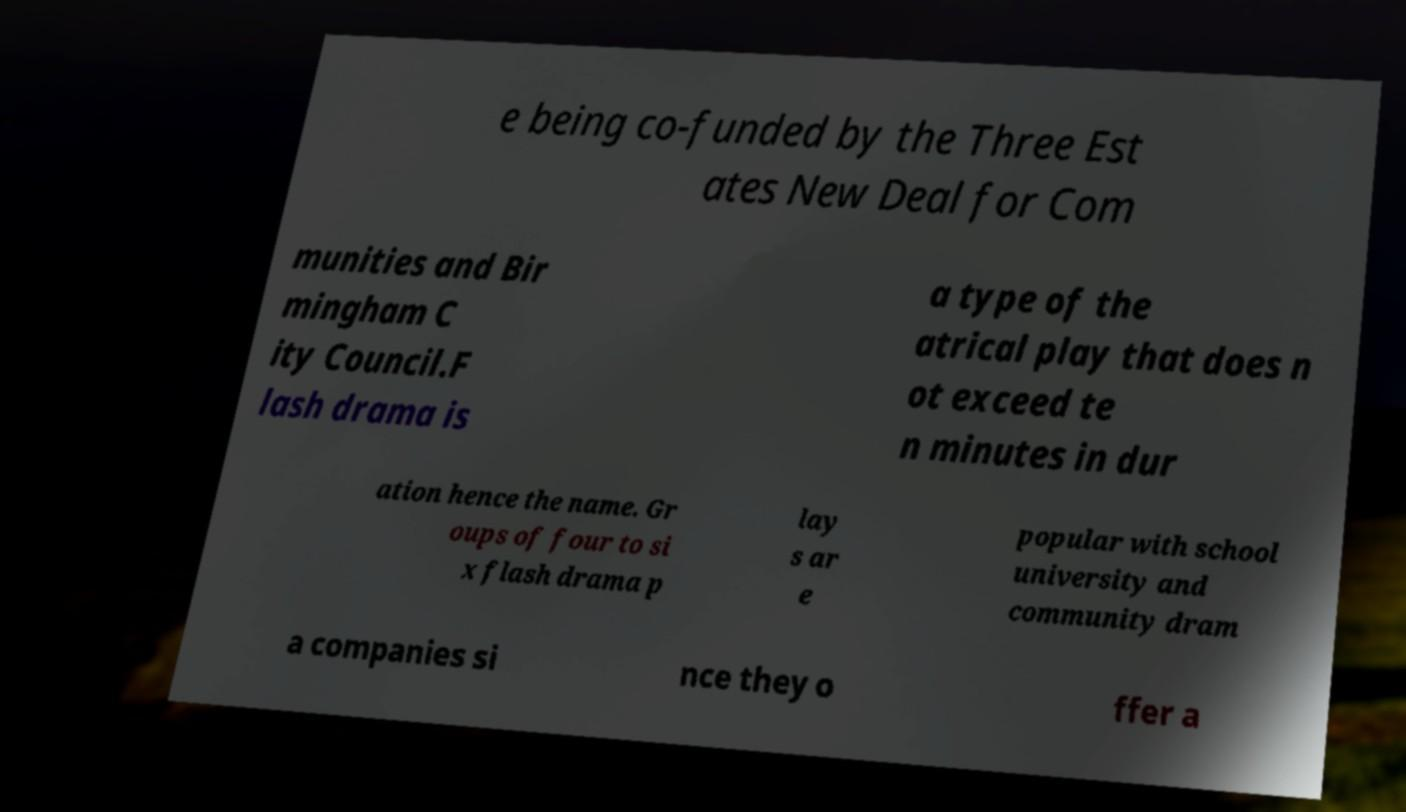Can you accurately transcribe the text from the provided image for me? e being co-funded by the Three Est ates New Deal for Com munities and Bir mingham C ity Council.F lash drama is a type of the atrical play that does n ot exceed te n minutes in dur ation hence the name. Gr oups of four to si x flash drama p lay s ar e popular with school university and community dram a companies si nce they o ffer a 